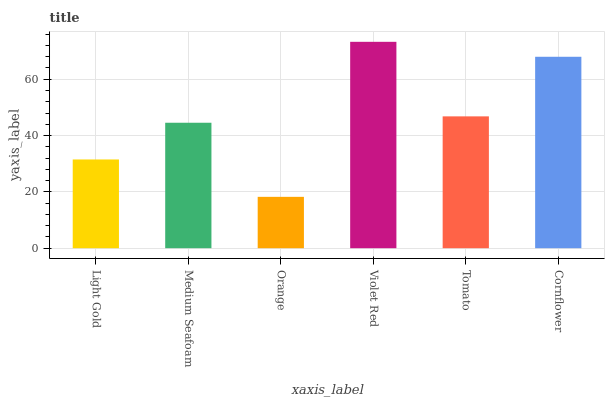Is Orange the minimum?
Answer yes or no. Yes. Is Violet Red the maximum?
Answer yes or no. Yes. Is Medium Seafoam the minimum?
Answer yes or no. No. Is Medium Seafoam the maximum?
Answer yes or no. No. Is Medium Seafoam greater than Light Gold?
Answer yes or no. Yes. Is Light Gold less than Medium Seafoam?
Answer yes or no. Yes. Is Light Gold greater than Medium Seafoam?
Answer yes or no. No. Is Medium Seafoam less than Light Gold?
Answer yes or no. No. Is Tomato the high median?
Answer yes or no. Yes. Is Medium Seafoam the low median?
Answer yes or no. Yes. Is Cornflower the high median?
Answer yes or no. No. Is Cornflower the low median?
Answer yes or no. No. 